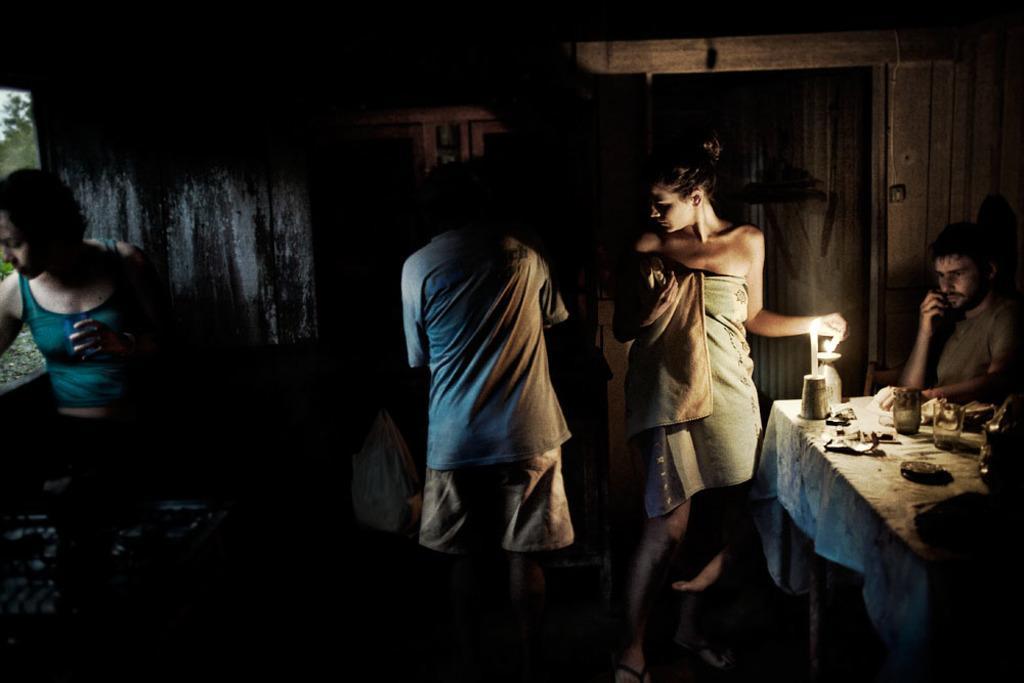Could you give a brief overview of what you see in this image? In this image I can see the dark picture in which I can see a person is sitting on a chair in front of a table and on the table I can see few glasses and few other objects. I can see few persons standing, the wooden wall and the window through which I can see few trees and the sky. 